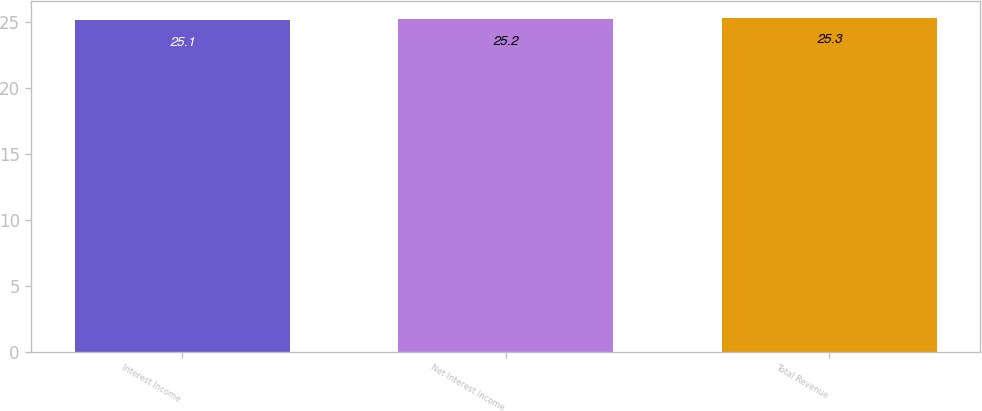<chart> <loc_0><loc_0><loc_500><loc_500><bar_chart><fcel>Interest Income<fcel>Net Interest Income<fcel>Total Revenue<nl><fcel>25.1<fcel>25.2<fcel>25.3<nl></chart> 